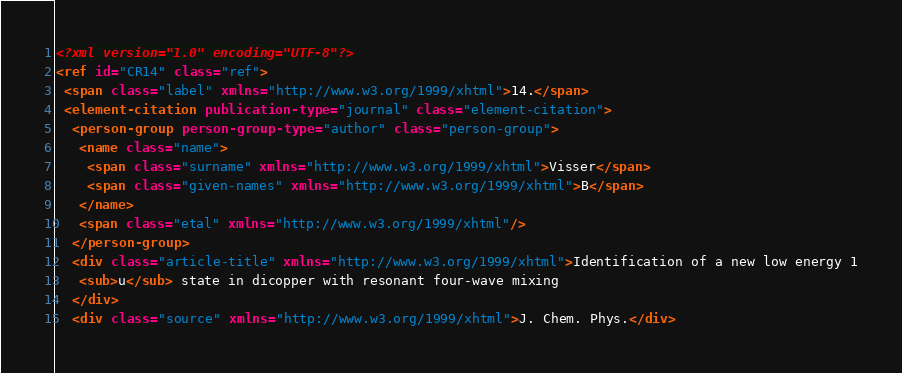<code> <loc_0><loc_0><loc_500><loc_500><_XML_><?xml version="1.0" encoding="UTF-8"?>
<ref id="CR14" class="ref">
 <span class="label" xmlns="http://www.w3.org/1999/xhtml">14.</span>
 <element-citation publication-type="journal" class="element-citation">
  <person-group person-group-type="author" class="person-group">
   <name class="name">
    <span class="surname" xmlns="http://www.w3.org/1999/xhtml">Visser</span>
    <span class="given-names" xmlns="http://www.w3.org/1999/xhtml">B</span>
   </name>
   <span class="etal" xmlns="http://www.w3.org/1999/xhtml"/>
  </person-group>
  <div class="article-title" xmlns="http://www.w3.org/1999/xhtml">Identification of a new low energy 1
   <sub>u</sub> state in dicopper with resonant four-wave mixing
  </div>
  <div class="source" xmlns="http://www.w3.org/1999/xhtml">J. Chem. Phys.</div></code> 